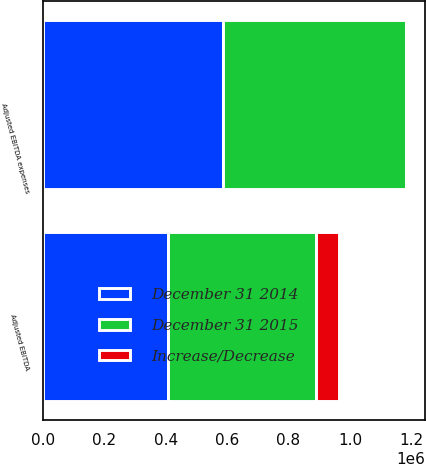Convert chart to OTSL. <chart><loc_0><loc_0><loc_500><loc_500><stacked_bar_chart><ecel><fcel>Adjusted EBITDA expenses<fcel>Adjusted EBITDA<nl><fcel>December 31 2015<fcel>593316<fcel>481697<nl><fcel>December 31 2014<fcel>587926<fcel>408754<nl><fcel>Increase/Decrease<fcel>5390<fcel>72943<nl></chart> 